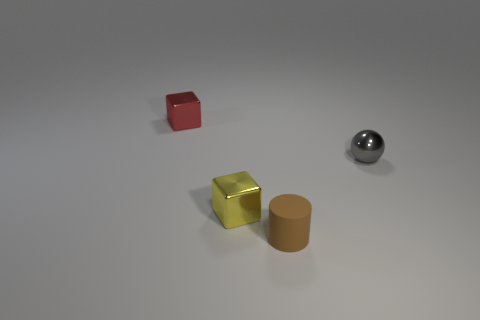Does the gray object have the same material as the red cube?
Offer a very short reply. Yes. Is the number of tiny spheres on the left side of the rubber thing greater than the number of tiny gray shiny objects?
Provide a succinct answer. No. What number of objects are small red objects or blocks behind the tiny gray ball?
Give a very brief answer. 1. Is the number of brown objects behind the gray sphere greater than the number of gray objects on the right side of the tiny yellow shiny object?
Provide a short and direct response. No. There is a cube in front of the tiny object right of the rubber thing right of the small yellow thing; what is its material?
Your response must be concise. Metal. What shape is the gray thing that is made of the same material as the red thing?
Ensure brevity in your answer.  Sphere. There is a thing right of the small cylinder; are there any red things behind it?
Ensure brevity in your answer.  Yes. How big is the brown rubber cylinder?
Your answer should be very brief. Small. How many objects are either tiny cyan spheres or tiny brown objects?
Your response must be concise. 1. Are the thing to the right of the small brown thing and the brown cylinder to the left of the tiny metallic ball made of the same material?
Give a very brief answer. No. 